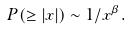Convert formula to latex. <formula><loc_0><loc_0><loc_500><loc_500>P ( \geq | x | ) \sim 1 / x ^ { \beta } .</formula> 